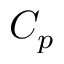Convert formula to latex. <formula><loc_0><loc_0><loc_500><loc_500>C _ { p }</formula> 